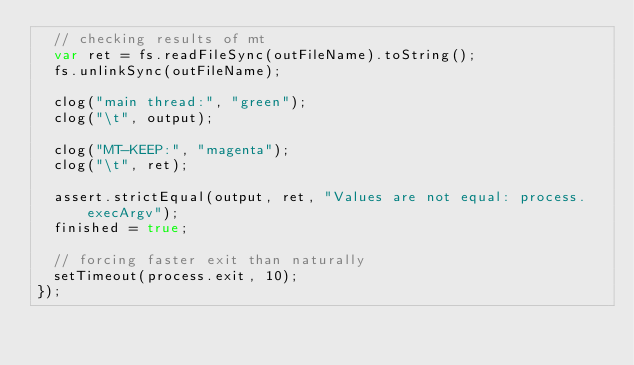Convert code to text. <code><loc_0><loc_0><loc_500><loc_500><_JavaScript_>  // checking results of mt
  var ret = fs.readFileSync(outFileName).toString();
  fs.unlinkSync(outFileName);

  clog("main thread:", "green");
  clog("\t", output);

  clog("MT-KEEP:", "magenta");
  clog("\t", ret);

  assert.strictEqual(output, ret, "Values are not equal: process.execArgv");
  finished = true;

  // forcing faster exit than naturally
  setTimeout(process.exit, 10);
});


</code> 